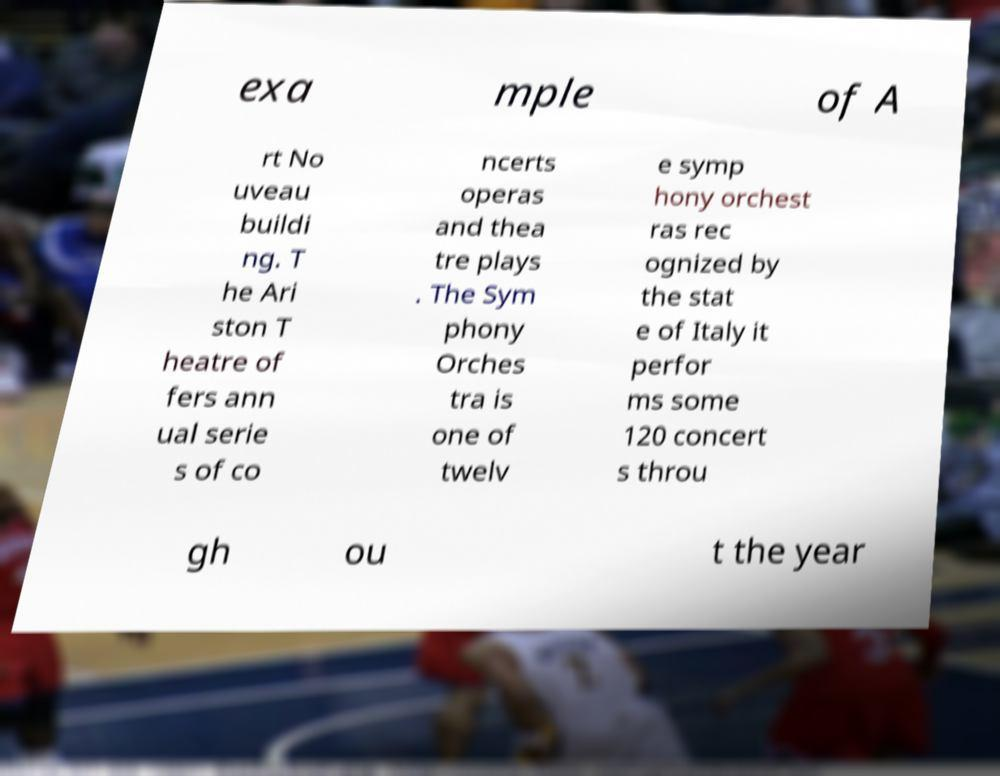I need the written content from this picture converted into text. Can you do that? exa mple of A rt No uveau buildi ng. T he Ari ston T heatre of fers ann ual serie s of co ncerts operas and thea tre plays . The Sym phony Orches tra is one of twelv e symp hony orchest ras rec ognized by the stat e of Italy it perfor ms some 120 concert s throu gh ou t the year 